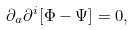Convert formula to latex. <formula><loc_0><loc_0><loc_500><loc_500>\partial _ { a } \partial ^ { i } [ \Phi - \Psi ] = 0 ,</formula> 